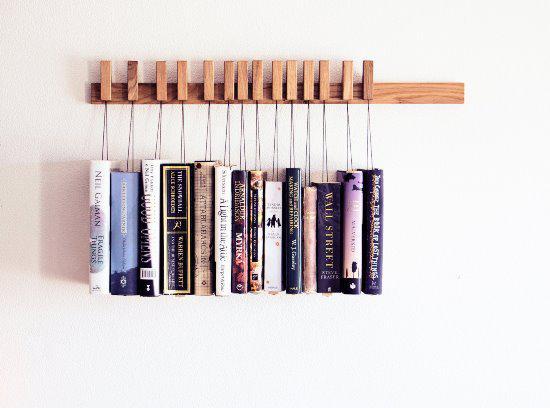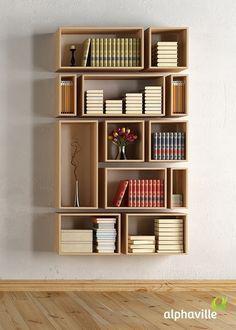The first image is the image on the left, the second image is the image on the right. Evaluate the accuracy of this statement regarding the images: "Books are hanging in traditional rectangular boxes on the wall in the image on the right.". Is it true? Answer yes or no. Yes. The first image is the image on the left, the second image is the image on the right. Assess this claim about the two images: "In one image, a rectangular shelf unit has been created by attaching individual wooden boxes to a wall, leaving open space between them where the wall is visible.". Correct or not? Answer yes or no. Yes. 